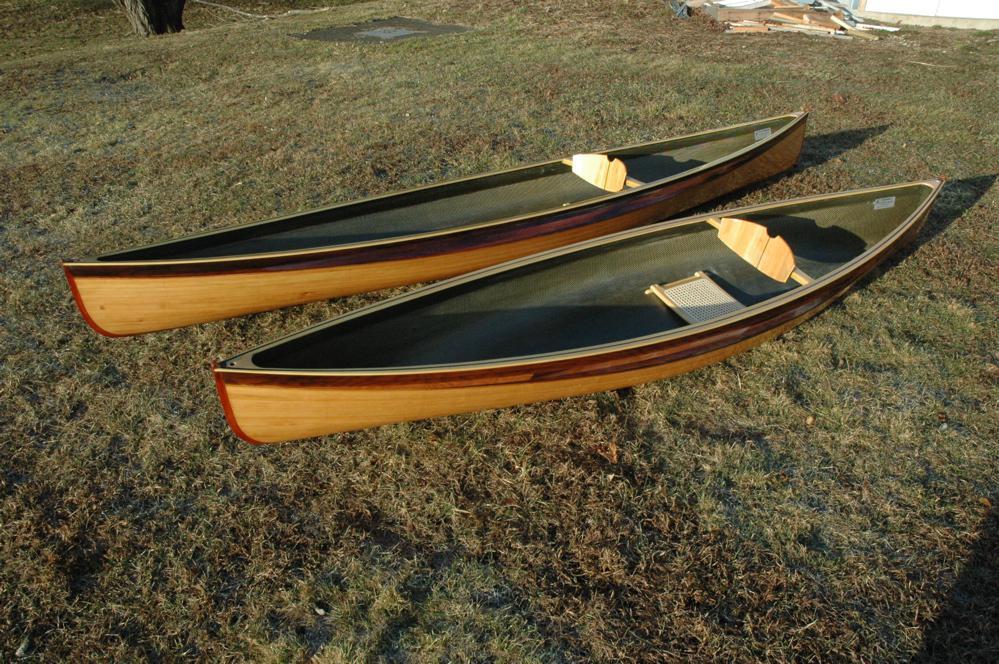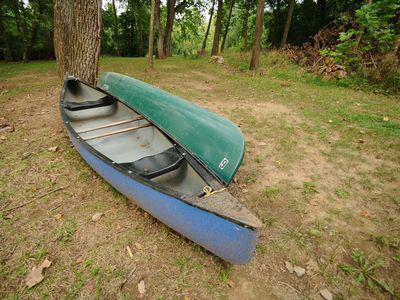The first image is the image on the left, the second image is the image on the right. Evaluate the accuracy of this statement regarding the images: "One image shows side-by-side woodgrain canoes on land, and the other image includes a green canoe.". Is it true? Answer yes or no. Yes. The first image is the image on the left, the second image is the image on the right. Analyze the images presented: Is the assertion "The left image contains two canoes laying next to each other in the grass." valid? Answer yes or no. Yes. 